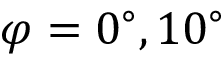Convert formula to latex. <formula><loc_0><loc_0><loc_500><loc_500>\varphi = { 0 ^ { \circ } } , { 1 0 ^ { \circ } }</formula> 